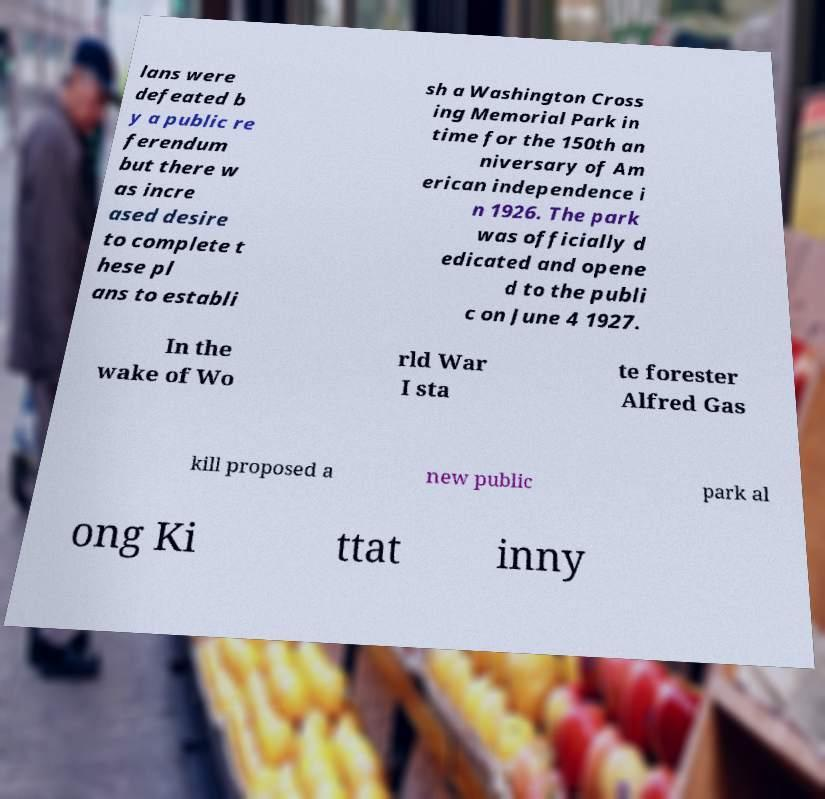Can you accurately transcribe the text from the provided image for me? lans were defeated b y a public re ferendum but there w as incre ased desire to complete t hese pl ans to establi sh a Washington Cross ing Memorial Park in time for the 150th an niversary of Am erican independence i n 1926. The park was officially d edicated and opene d to the publi c on June 4 1927. In the wake of Wo rld War I sta te forester Alfred Gas kill proposed a new public park al ong Ki ttat inny 